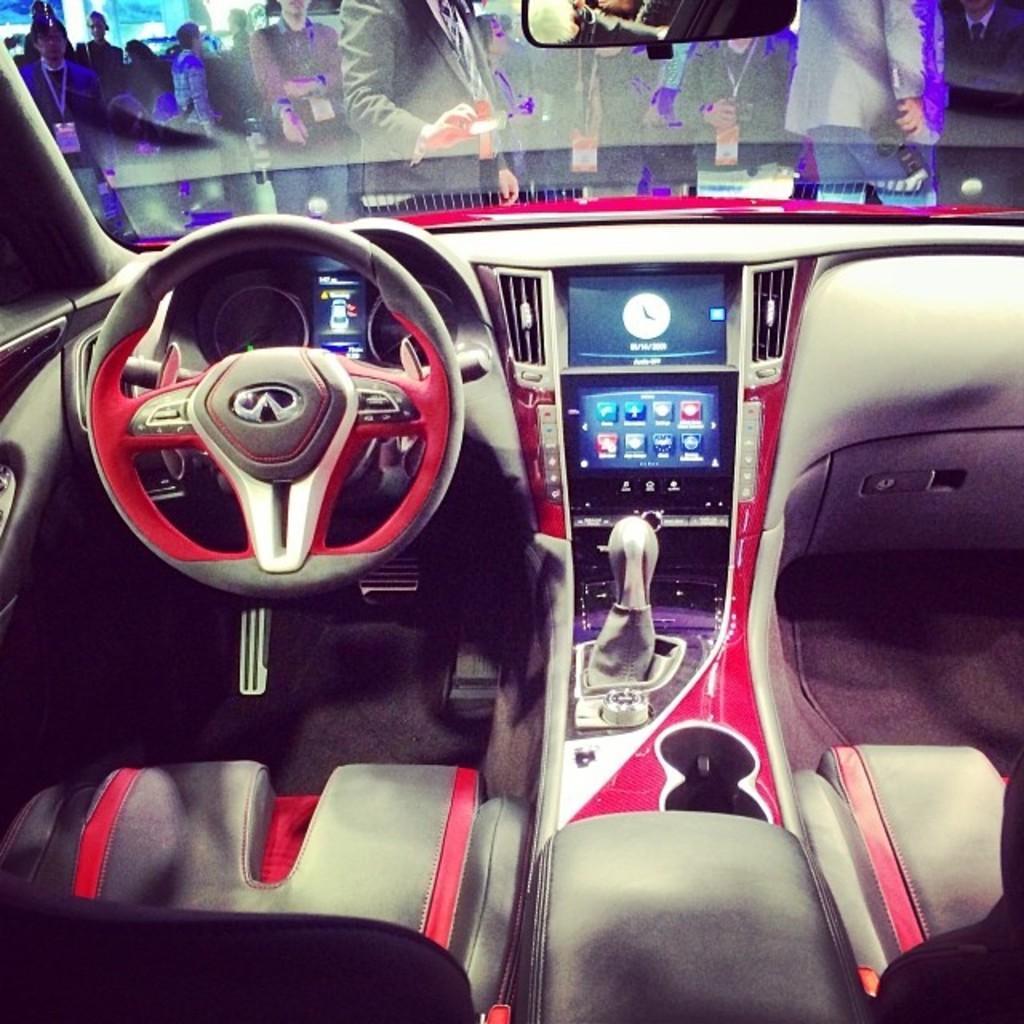Could you give a brief overview of what you see in this image? In this image we can see inside view of a vehicle in which we can see screens, clock and a mirror. In the background, we can see some people standing. One person is holding a device in his hand. One man is holding a camera in his hand. 